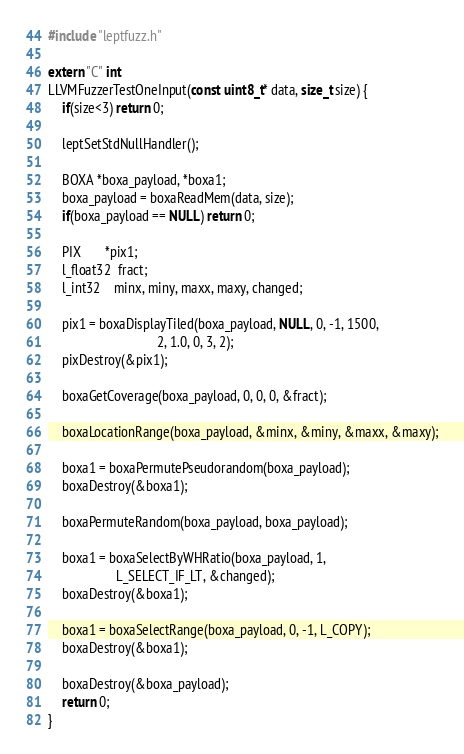<code> <loc_0><loc_0><loc_500><loc_500><_C++_>#include "leptfuzz.h"

extern "C" int
LLVMFuzzerTestOneInput(const uint8_t* data, size_t size) { 
	if(size<3) return 0;
 
	leptSetStdNullHandler();

	BOXA *boxa_payload, *boxa1;
	boxa_payload = boxaReadMem(data, size);
	if(boxa_payload == NULL) return 0;

	PIX       *pix1;
	l_float32  fract;
	l_int32    minx, miny, maxx, maxy, changed;
	
	pix1 = boxaDisplayTiled(boxa_payload, NULL, 0, -1, 1500,
                                2, 1.0, 0, 3, 2);
	pixDestroy(&pix1);

	boxaGetCoverage(boxa_payload, 0, 0, 0, &fract);

	boxaLocationRange(boxa_payload, &minx, &miny, &maxx, &maxy);

	boxa1 = boxaPermutePseudorandom(boxa_payload);
	boxaDestroy(&boxa1);

	boxaPermuteRandom(boxa_payload, boxa_payload);

	boxa1 = boxaSelectByWHRatio(boxa_payload, 1, 
				    L_SELECT_IF_LT, &changed);
	boxaDestroy(&boxa1);

	boxa1 = boxaSelectRange(boxa_payload, 0, -1, L_COPY);
	boxaDestroy(&boxa1);

	boxaDestroy(&boxa_payload);
	return 0;
}
</code> 